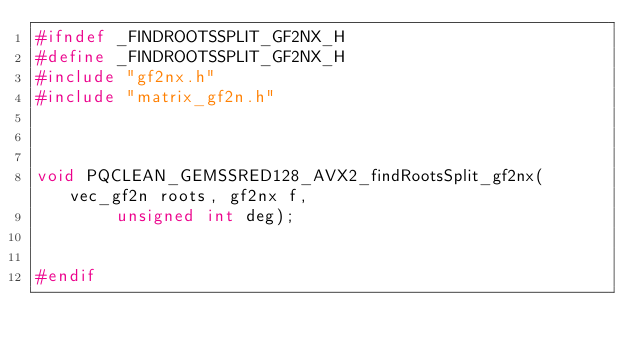<code> <loc_0><loc_0><loc_500><loc_500><_C_>#ifndef _FINDROOTSSPLIT_GF2NX_H
#define _FINDROOTSSPLIT_GF2NX_H
#include "gf2nx.h"
#include "matrix_gf2n.h"



void PQCLEAN_GEMSSRED128_AVX2_findRootsSplit_gf2nx(vec_gf2n roots, gf2nx f,
        unsigned int deg);


#endif
</code> 